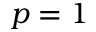<formula> <loc_0><loc_0><loc_500><loc_500>p = 1</formula> 